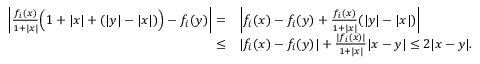Convert formula to latex. <formula><loc_0><loc_0><loc_500><loc_500>\begin{array} { r l } { \left | \frac { f _ { i } ( x ) } { 1 + | x | } \left ( 1 + | x | + ( | y | - | x | ) \right ) - f _ { i } ( y ) \right | = } & { \left | f _ { i } ( x ) - f _ { i } ( y ) + \frac { f _ { i } ( x ) } { 1 + | x | } ( | y | - | x | ) \right | } \\ { \leq } & { | f _ { i } ( x ) - f _ { i } ( y ) | + \frac { | f _ { i } ( x ) | } { 1 + | x | } | x - y | \leq 2 | x - y | . } \end{array}</formula> 